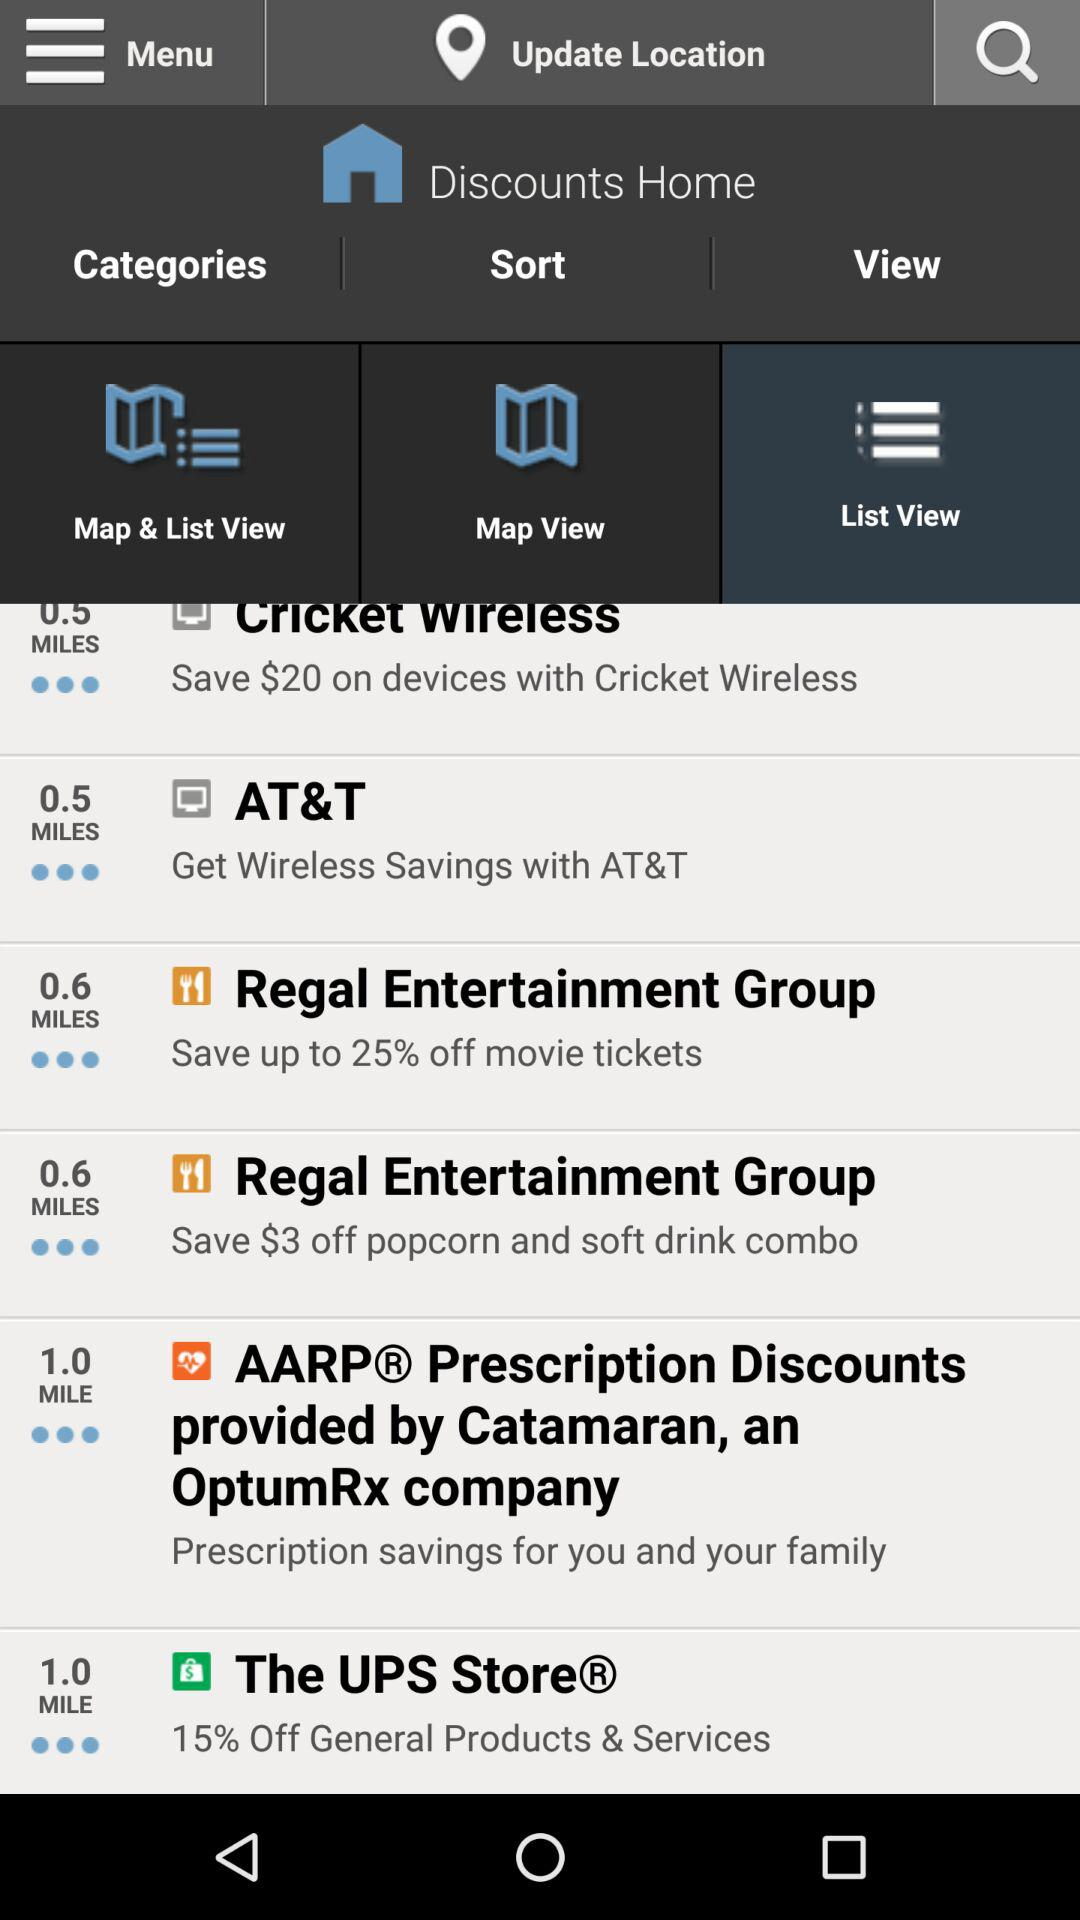Which store offers the most discounts?
Answer the question using a single word or phrase. Cricket Wireless 